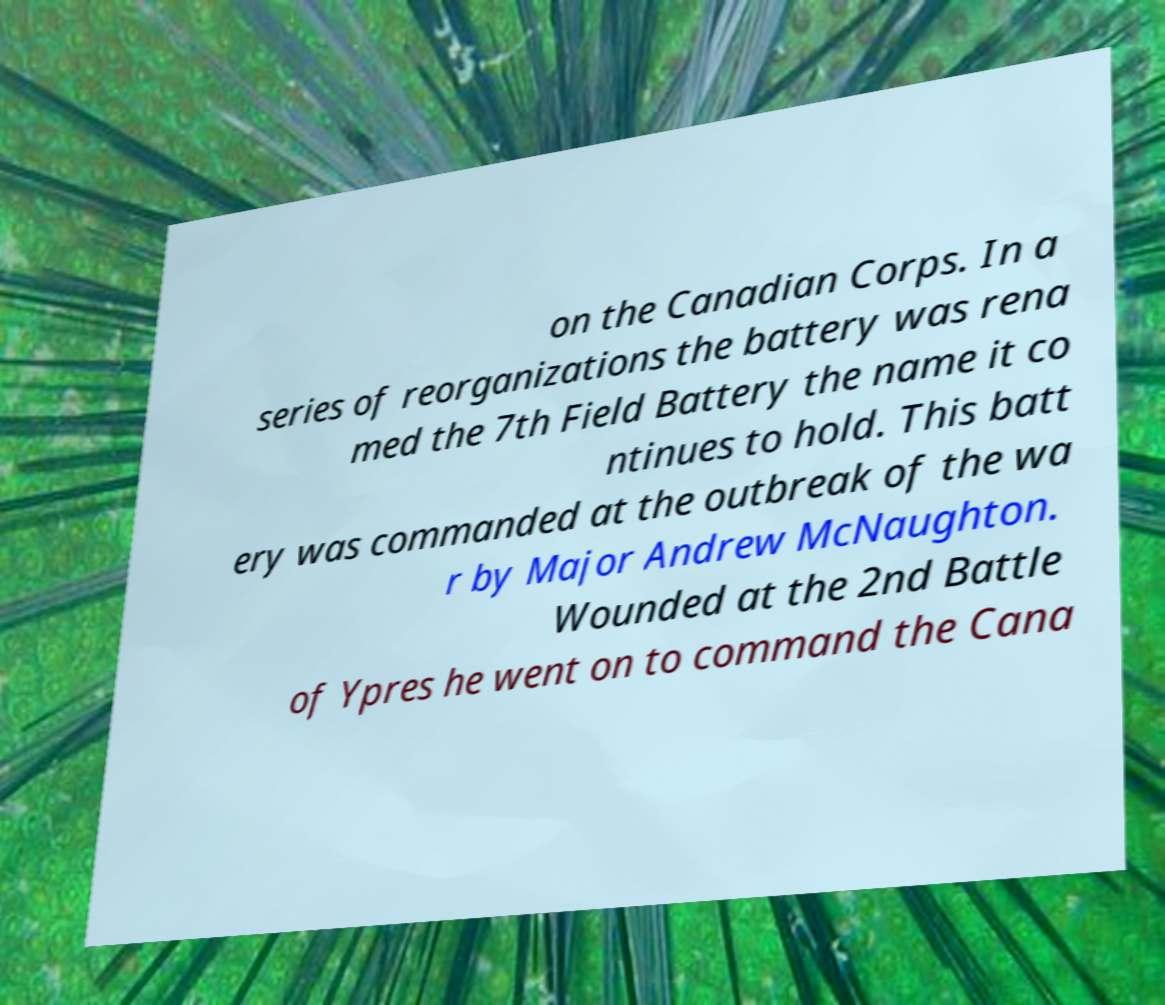Can you accurately transcribe the text from the provided image for me? on the Canadian Corps. In a series of reorganizations the battery was rena med the 7th Field Battery the name it co ntinues to hold. This batt ery was commanded at the outbreak of the wa r by Major Andrew McNaughton. Wounded at the 2nd Battle of Ypres he went on to command the Cana 